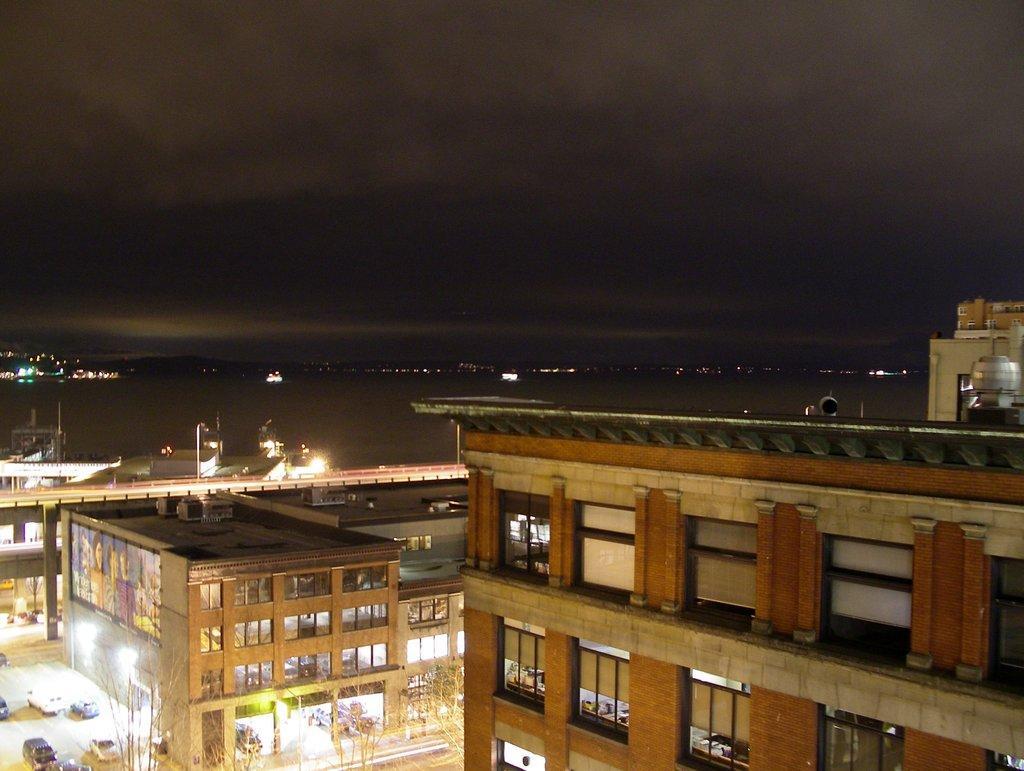Could you give a brief overview of what you see in this image? This is an aerial view image of a town, there are buildings with many windows all over it, on the left side there are many vehicles going on the road and lights illuminating inside the building and above its sky with clouds, this is clicked at night time. 